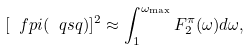Convert formula to latex. <formula><loc_0><loc_0><loc_500><loc_500>[ \ f p i ( \ q s q ) ] ^ { 2 } \approx \int _ { 1 } ^ { \omega _ { \max } } F _ { 2 } ^ { \pi } ( \omega ) d \omega ,</formula> 